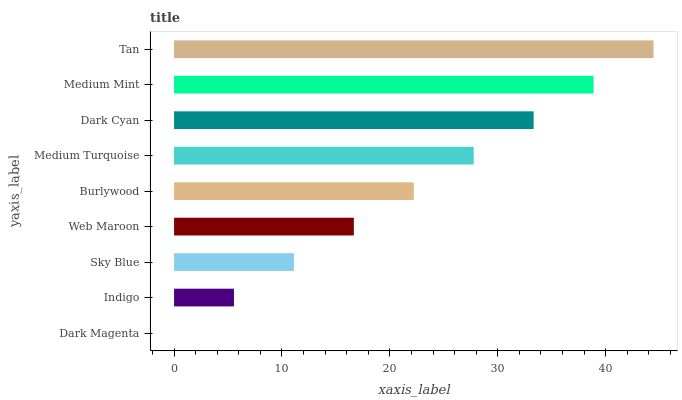Is Dark Magenta the minimum?
Answer yes or no. Yes. Is Tan the maximum?
Answer yes or no. Yes. Is Indigo the minimum?
Answer yes or no. No. Is Indigo the maximum?
Answer yes or no. No. Is Indigo greater than Dark Magenta?
Answer yes or no. Yes. Is Dark Magenta less than Indigo?
Answer yes or no. Yes. Is Dark Magenta greater than Indigo?
Answer yes or no. No. Is Indigo less than Dark Magenta?
Answer yes or no. No. Is Burlywood the high median?
Answer yes or no. Yes. Is Burlywood the low median?
Answer yes or no. Yes. Is Tan the high median?
Answer yes or no. No. Is Medium Mint the low median?
Answer yes or no. No. 